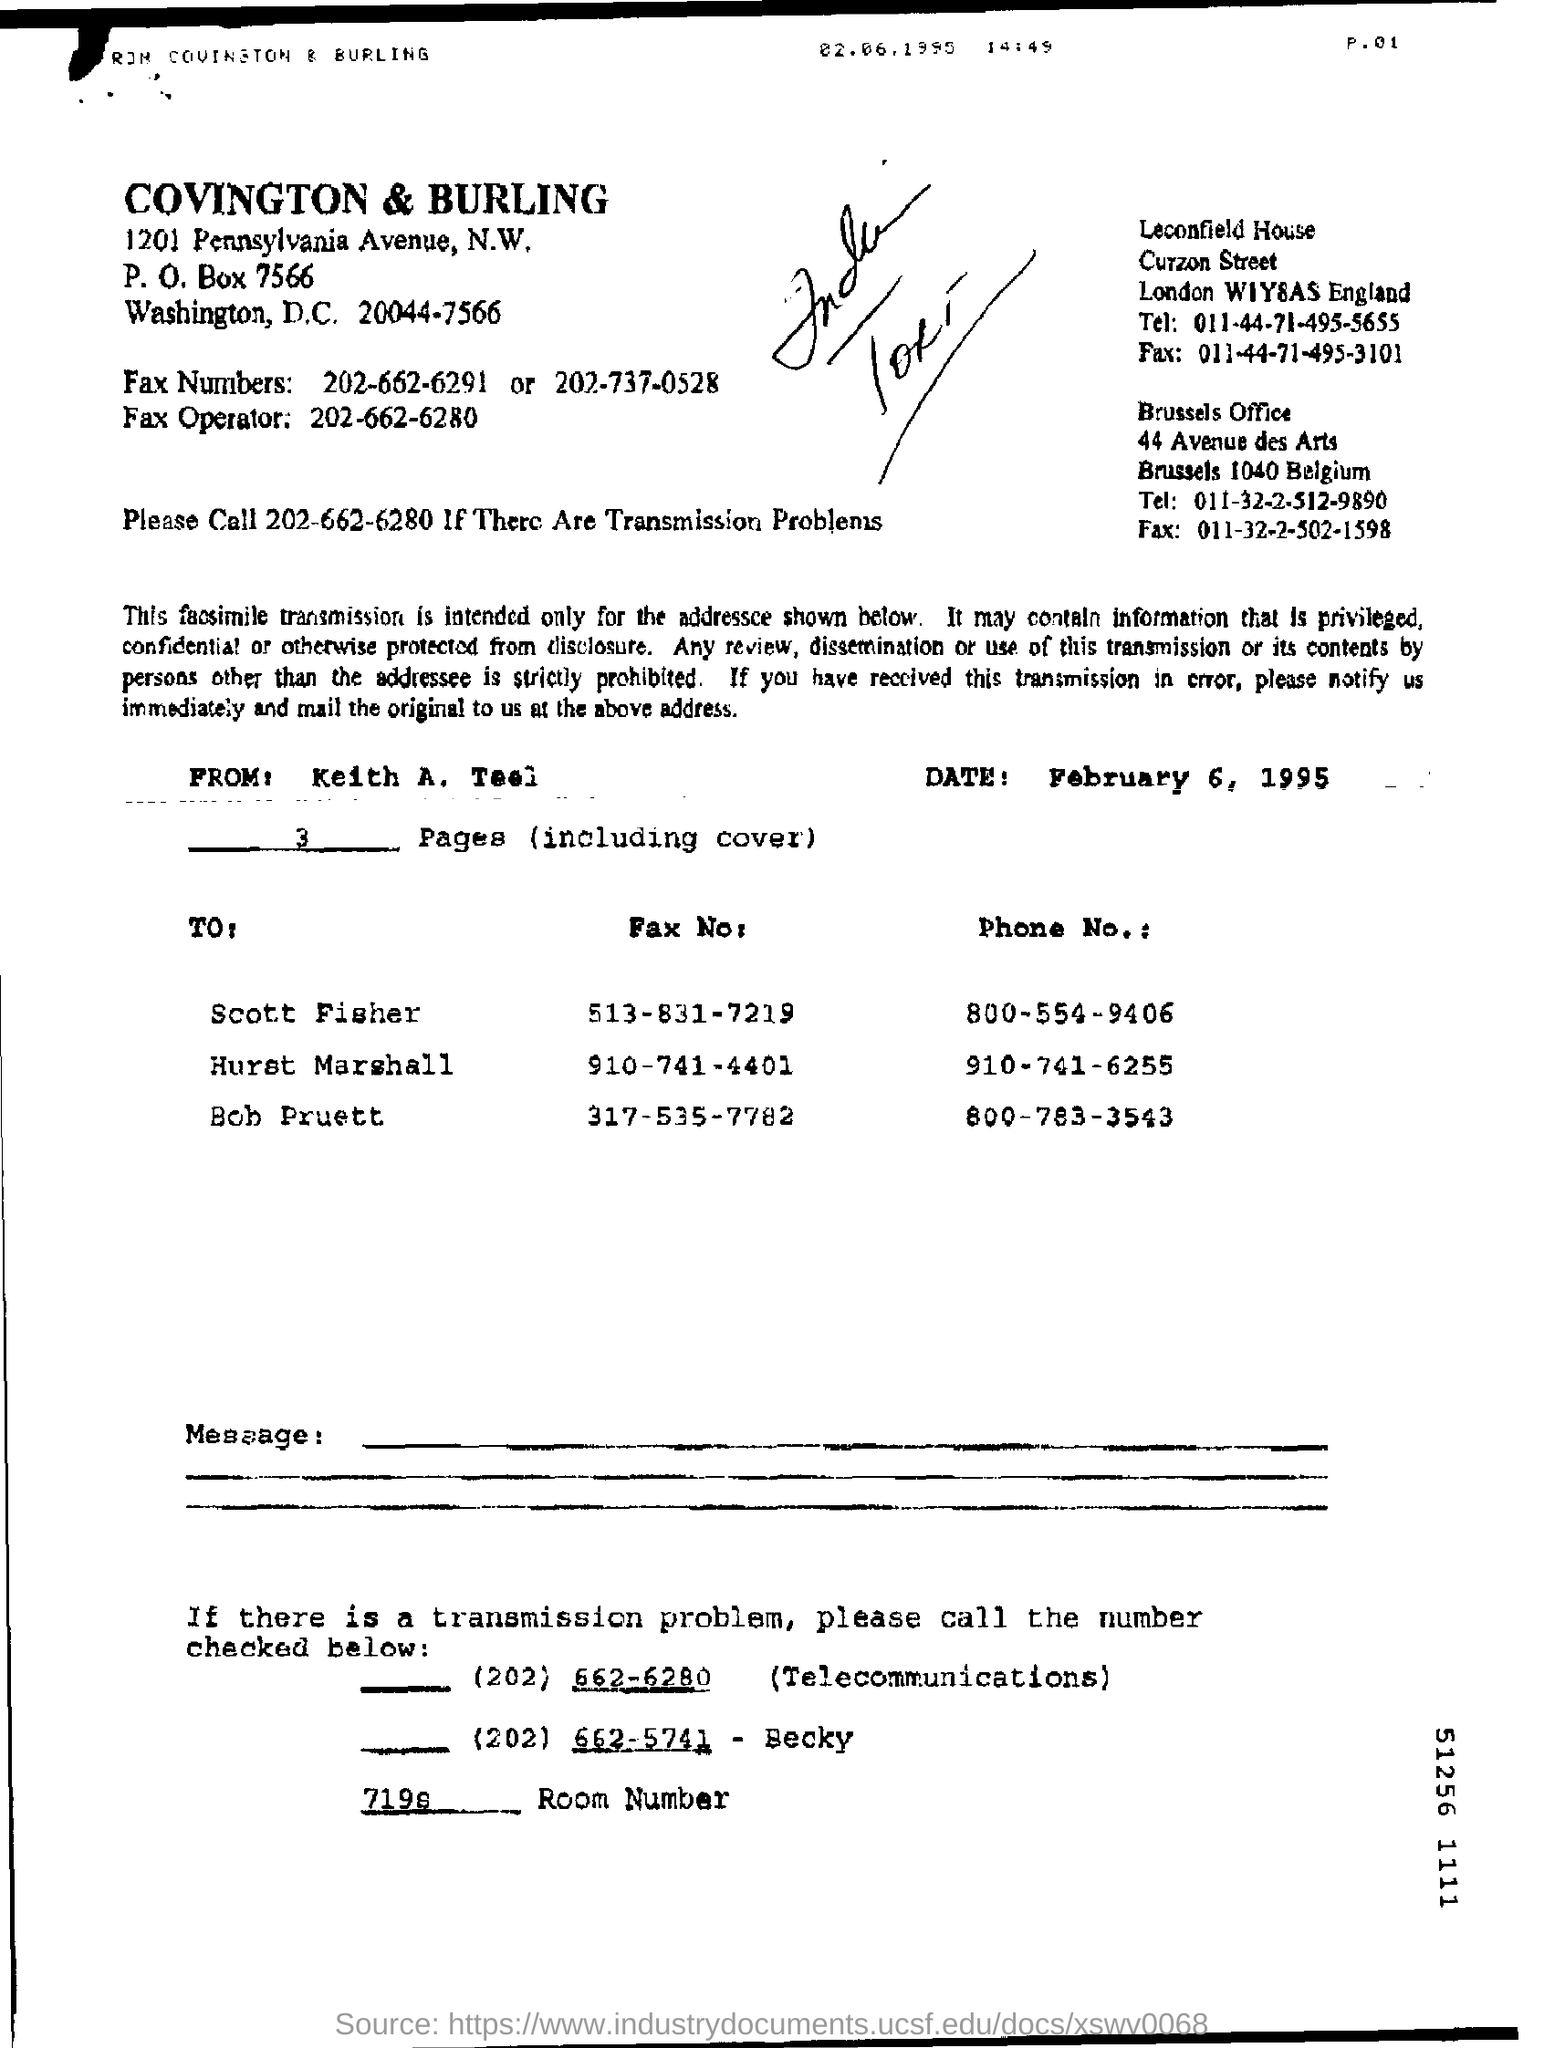What is the date on the document?
Your answer should be very brief. February 6, 1995. Who is this letter from?
Offer a very short reply. Keith A. Teel. What is the Phone No. for Scott Fisher?
Offer a very short reply. 800-554-9406. What is the Phone No. for Bob Pruett?
Give a very brief answer. 800-783-3543. 